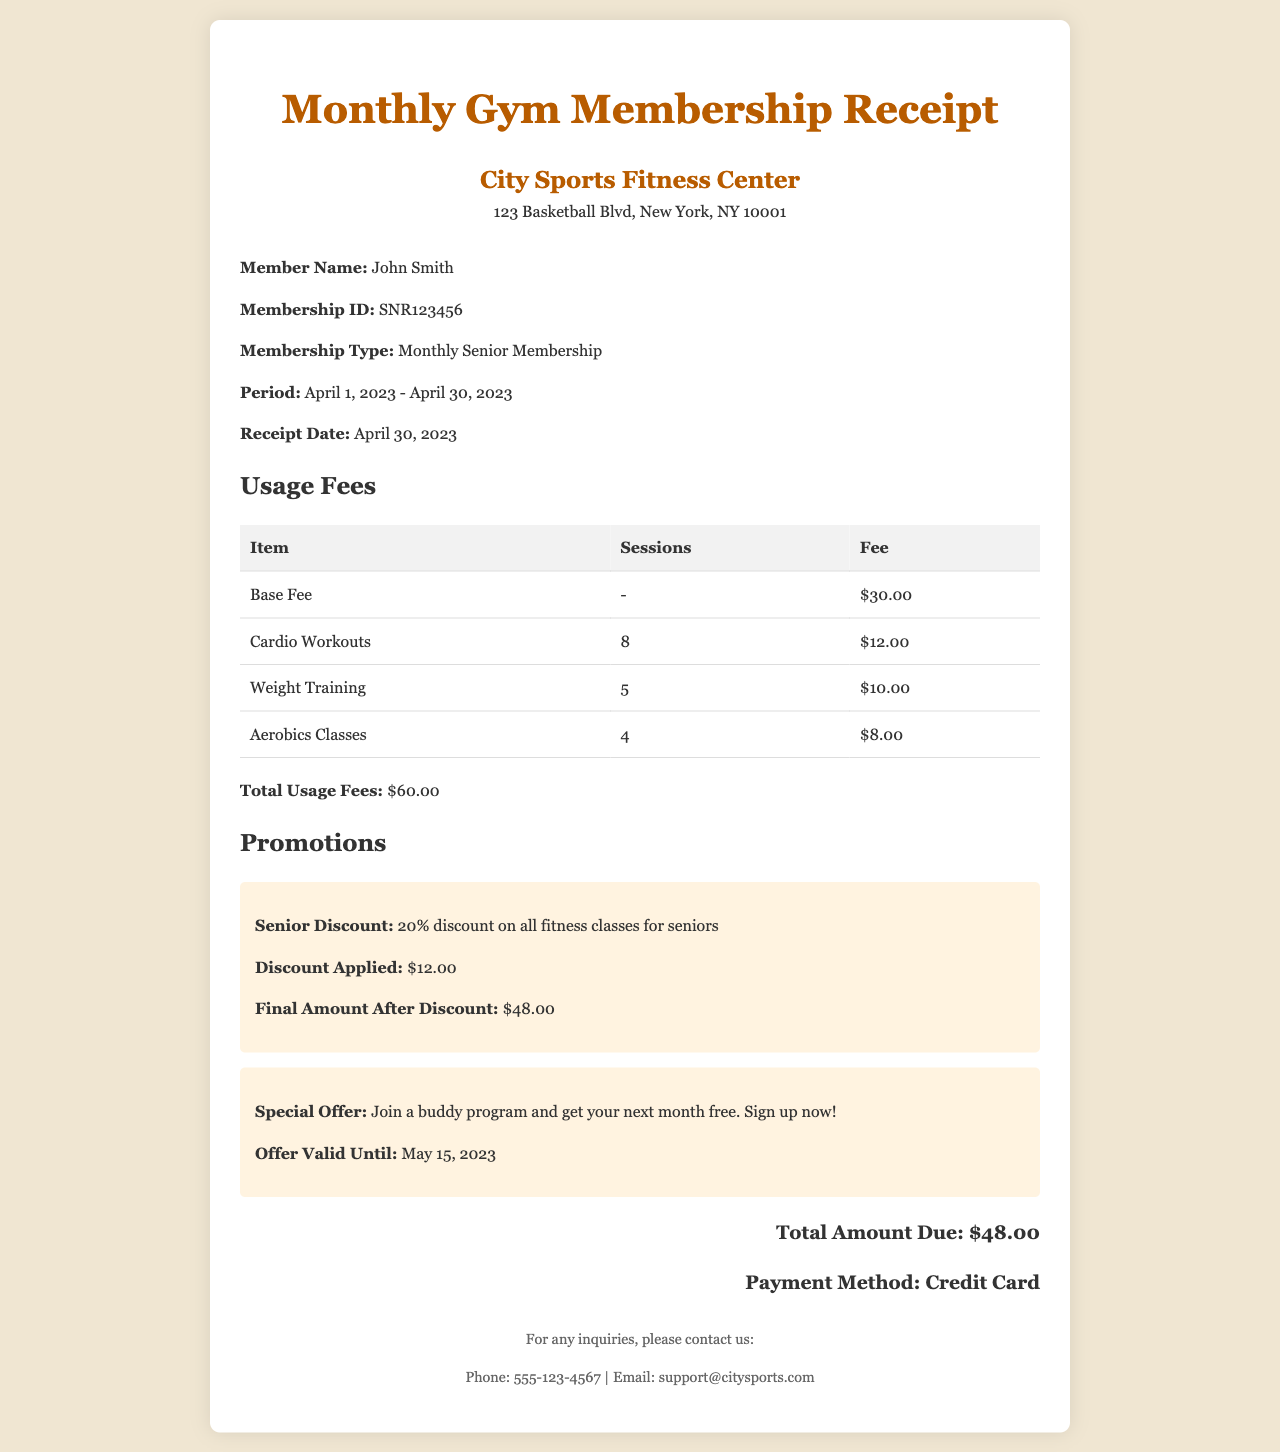What is the member's name? The member's name is provided in the document as John Smith.
Answer: John Smith What is the membership ID? The membership ID is shown in the member information section as SNR123456.
Answer: SNR123456 What is the period of the membership? The period of the membership indicates the start and end dates, which is specified as April 1, 2023 - April 30, 2023.
Answer: April 1, 2023 - April 30, 2023 What is the total amount due? The total amount due is calculated at the end of the document, which is stated as $48.00.
Answer: $48.00 How much is the senior discount? The senior discount is explained in the promotions section, which indicates a 20% discount on all fitness classes for seniors.
Answer: 20% What is the total usage fee before discounts? The document states the total usage fees before applying any discounts, which is $60.00.
Answer: $60.00 How much was the discount applied? The discount applied is shown in the promotions section as $12.00.
Answer: $12.00 What special offer is available for seniors? The special offer is described as joining a buddy program to get the next month free.
Answer: Join a buddy program What is the payment method used? The payment method is listed at the bottom of the receipt, which indicates it was made by credit card.
Answer: Credit Card When does the special offer expire? The expiration date for the special offer is provided as May 15, 2023.
Answer: May 15, 2023 